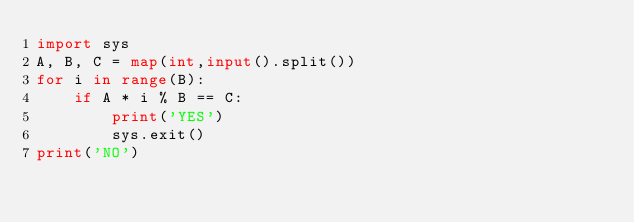Convert code to text. <code><loc_0><loc_0><loc_500><loc_500><_Python_>import sys
A, B, C = map(int,input().split())
for i in range(B):
    if A * i % B == C:
        print('YES')
        sys.exit()
print('NO')</code> 